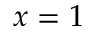<formula> <loc_0><loc_0><loc_500><loc_500>x = 1</formula> 